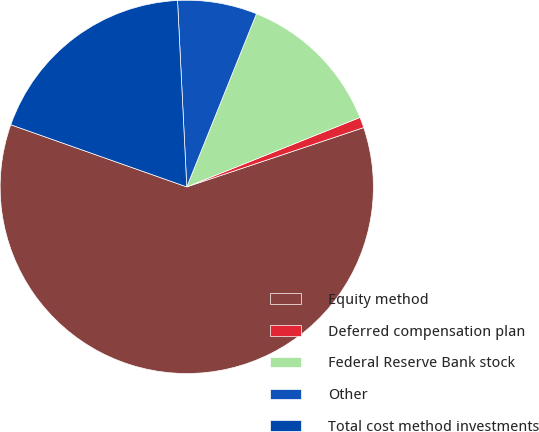Convert chart to OTSL. <chart><loc_0><loc_0><loc_500><loc_500><pie_chart><fcel>Equity method<fcel>Deferred compensation plan<fcel>Federal Reserve Bank stock<fcel>Other<fcel>Total cost method investments<nl><fcel>60.55%<fcel>0.92%<fcel>12.84%<fcel>6.88%<fcel>18.81%<nl></chart> 